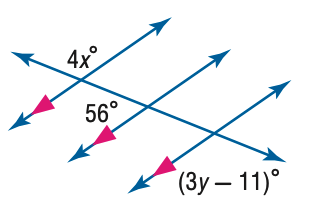Question: Find y in the figure.
Choices:
A. 35
B. 40
C. 45
D. 50
Answer with the letter. Answer: C Question: Find x in the figure.
Choices:
A. 21
B. 26
C. 31
D. 36
Answer with the letter. Answer: C 